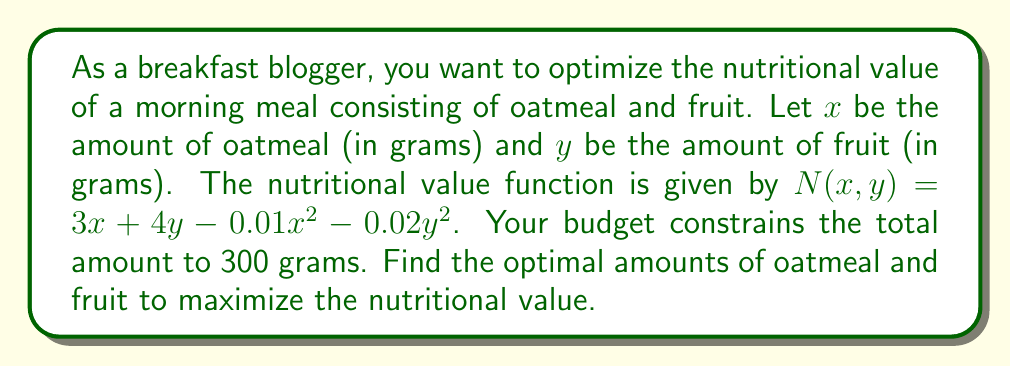Can you solve this math problem? 1) We need to maximize $N(x,y) = 3x + 4y - 0.01x^2 - 0.02y^2$ subject to the constraint $x + y = 300$.

2) Use the method of Lagrange multipliers. Let $\lambda$ be the Lagrange multiplier.
   $L(x,y,\lambda) = 3x + 4y - 0.01x^2 - 0.02y^2 - \lambda(x + y - 300)$

3) Take partial derivatives and set them to zero:
   $\frac{\partial L}{\partial x} = 3 - 0.02x - \lambda = 0$
   $\frac{\partial L}{\partial y} = 4 - 0.04y - \lambda = 0$
   $\frac{\partial L}{\partial \lambda} = x + y - 300 = 0$

4) From the first two equations:
   $3 - 0.02x = 4 - 0.04y$
   $0.04y - 0.02x = 1$
   $2y - x = 50$ ... (1)

5) Substitute this into the constraint equation:
   $x + y = 300$
   $x + \frac{x+50}{2} = 300$
   $3x = 550$
   $x = \frac{550}{3} \approx 183.33$

6) Substitute this x value back into equation (1):
   $2y - 183.33 = 50$
   $2y = 233.33$
   $y = 116.67$

7) Check that $x + y = 183.33 + 116.67 = 300$, satisfying the constraint.

8) The maximum nutritional value is:
   $N(183.33, 116.67) = 3(183.33) + 4(116.67) - 0.01(183.33)^2 - 0.02(116.67)^2 \approx 825.69$
Answer: Oatmeal: 183.33g, Fruit: 116.67g, Max nutritional value: 825.69 